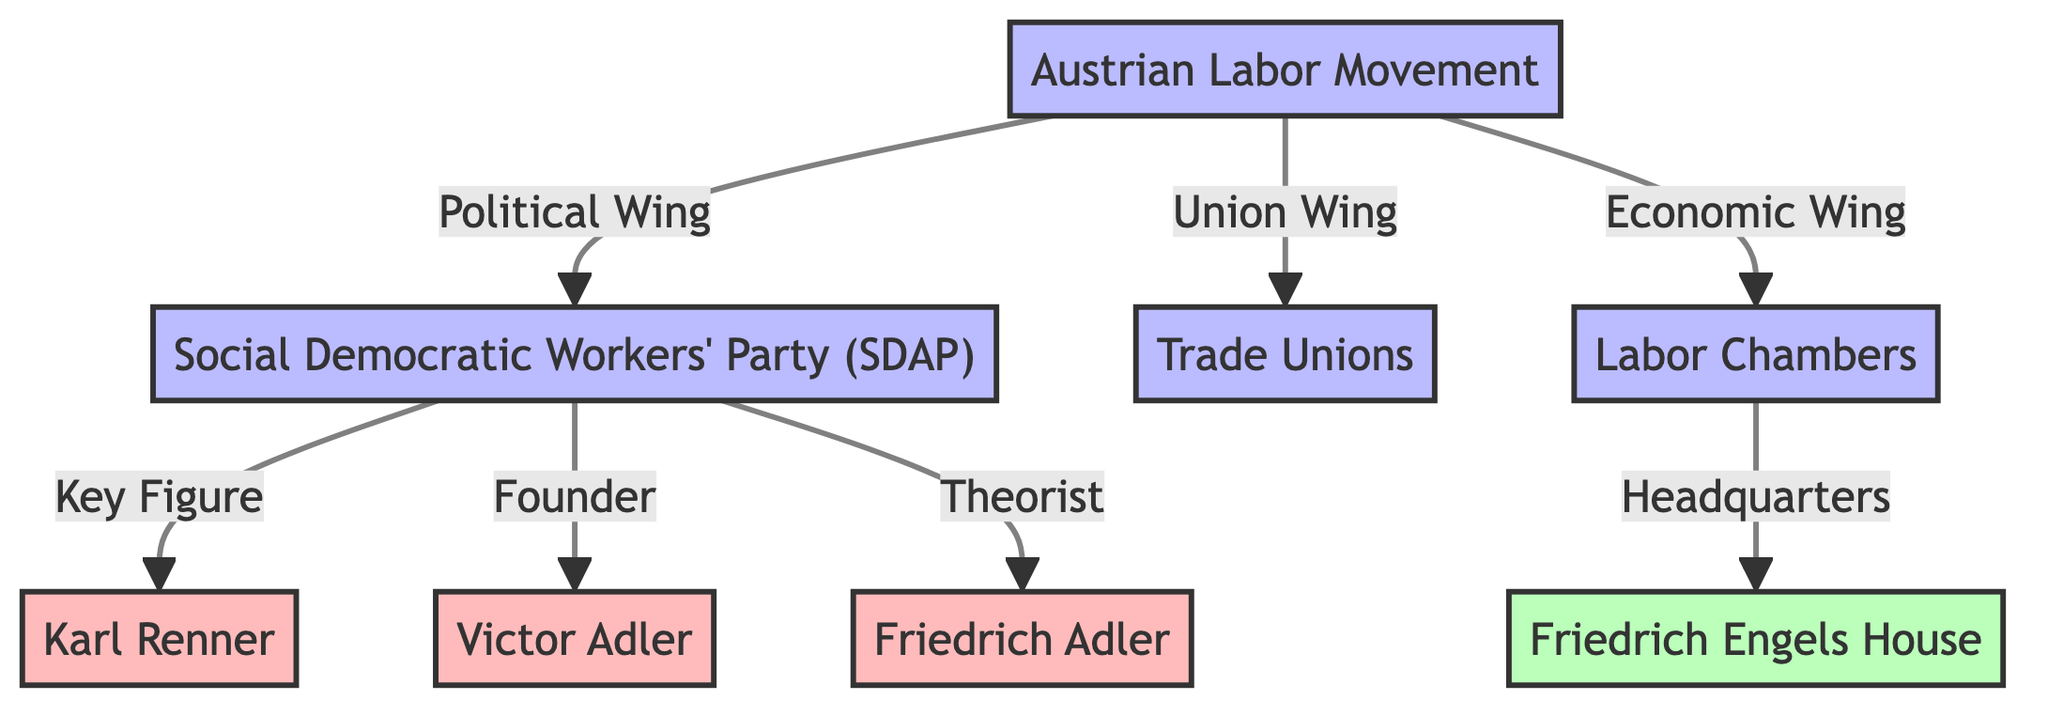What is the political wing of the Austrian Labor Movement? The political wing is represented by the Social Democratic Workers' Party (SDAP) in the diagram. This can be seen as a direct connection labeled "Political Wing" from the Austrian Labor Movement node to the SDAP node.
Answer: Social Democratic Workers' Party (SDAP) How many key figures are associated with the Social Democratic Workers' Party (SDAP)? There are three key figures connected to the SDAP: Karl Renner, Victor Adler, and Friedrich Adler. The diagram shows these individuals connected directly under the SDAP node, indicating their significance to the organization.
Answer: 3 Which organization serves as the economic wing of the Austrian Labor Movement? The Labor Chambers serve as the economic wing, as seen in the diagram where the connection labeled "Economic Wing" leads from the Austrian Labor Movement node to the Labor Chambers node.
Answer: Labor Chambers Who is noted as the founder of the Social Democratic Workers' Party (SDAP)? Victor Adler is mentioned as the founder of the SDAP in the diagram, where it states "Founder" alongside the name Victor Adler linked to the SDAP node.
Answer: Victor Adler What location is identified as the headquarters of the Labor Chambers? The headquarters is identified as Friedrich Engels House in the diagram, shown by the path leading from the Labor Chambers node and labeled "Headquarters."
Answer: Friedrich Engels House How is Friedrich Adler characterized in the diagram? Friedrich Adler is characterized as a theorist according to the connection labeled "Theorist" linked to his node under the SDAP. This indicates his role and contribution to the organization beyond just being a key figure.
Answer: Theorist What type of relationships connect the Austrian Labor Movement to its wings? The relationships are labeled as "Political Wing," "Union Wing," and "Economic Wing," showcasing the organization’s structure and its segmentation into different functionalities in labor representation.
Answer: Political Wing, Union Wing, Economic Wing Which node connects to the Trade Unions category in the Austrian Labor Movement? The Trade Unions category is a wing of the Austrian Labor Movement directly connected through the "Union Wing" link. This indicates the labor representation orientation of this organization.
Answer: Trade Unions 